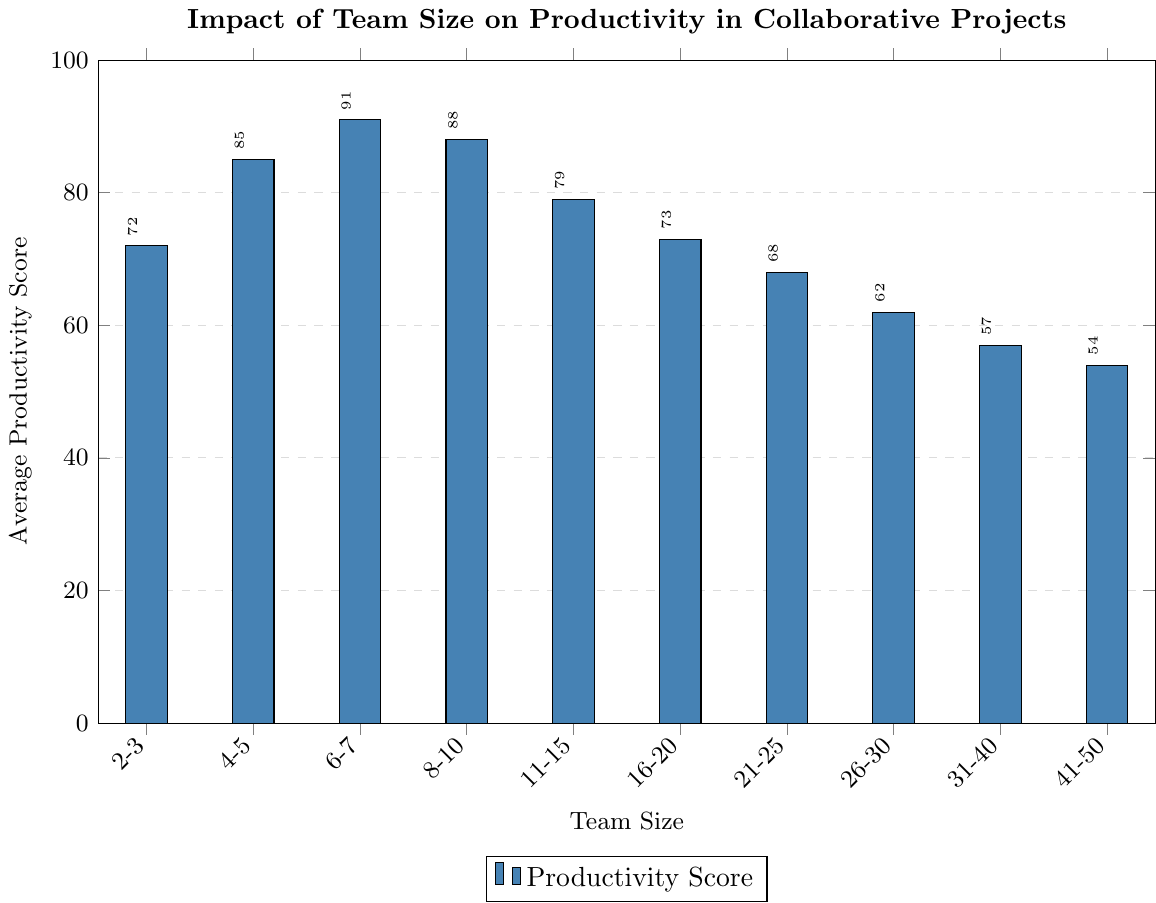What's the average productivity score of teams with more than 20 members? Sum the productivity scores for teams with 21-25, 26-30, 31-40, and 41-50 members, which are 68, 62, 57, and 54. Then divide the sum by 4. Calculation: (68 + 62 + 57 + 54) / 4 = 241 / 4 = 60.25
Answer: 60.25 Which team size has the highest average productivity score? Look for the tallest bar in the chart which represents the highest value. The highest bar corresponds to the team size of 6-7 members with a score of 91.
Answer: 6-7 members Is the productivity score for teams of 4-5 members higher or lower than teams of 8-10 members? Identify the height of bars for 4-5 members and 8-10 members. The score for 4-5 members is 85 and for 8-10 members is 88, so 4-5 members are lower than 8-10 members.
Answer: Lower What is the difference in productivity score between the smallest and the largest teams? Subtract the score of the largest teams (41-50 members) from the score of the smallest teams (2-3 members). Calculation: 72 - 54 = 18.
Answer: 18 Between which team sizes is the productivity score most consistent (smallest range in values)? Calculate the range (difference between the maximum and minimum scores) for each adjacent team size group and find the smallest range. Observing the values, team sizes 16-20 and 21-25 have close scores of 73 and 68. So, their range is: 73 - 68 = 5, which is the smallest.
Answer: 16-20 and 21-25 members What is the average productivity score of teams with fewer than 8 members? Add the productivity scores for team sizes 2-3, 4-5, and 6-7. Then divide by the number of these groups. Calculation: (72 + 85 + 91) / 3 = 248 / 3 = 82.67.
Answer: 82.67 Is there any team size with a productivity score below 60? If so, which ones? Examine the bars with values lower than 60. The team sizes with scores below 60 are 31-40 members (57) and 41-50 members (54).
Answer: 31-40 members and 41-50 members How much higher is the productivity score for teams of 6-7 members compared to teams of 11-15 members? Subtract the score of 11-15 members from the score of 6-7 members. Calculation: 91 - 79 = 12.
Answer: 12 What's the median productivity score for all team sizes? List all productivity scores in order: 54, 57, 62, 68, 72, 73, 79, 85, 88, 91. The median is the average of the 5th and 6th scores when ordered. Calculation: (72 + 73) / 2 = 145 / 2 = 72.5.
Answer: 72.5 How does the productivity score change as team size increases from 2-3 members to 6-7 members? List the productivity scores and note the trend: 2-3 members (72), 4-5 members (85), 6-7 members (91). The scores increase as the team size increases.
Answer: Increases 